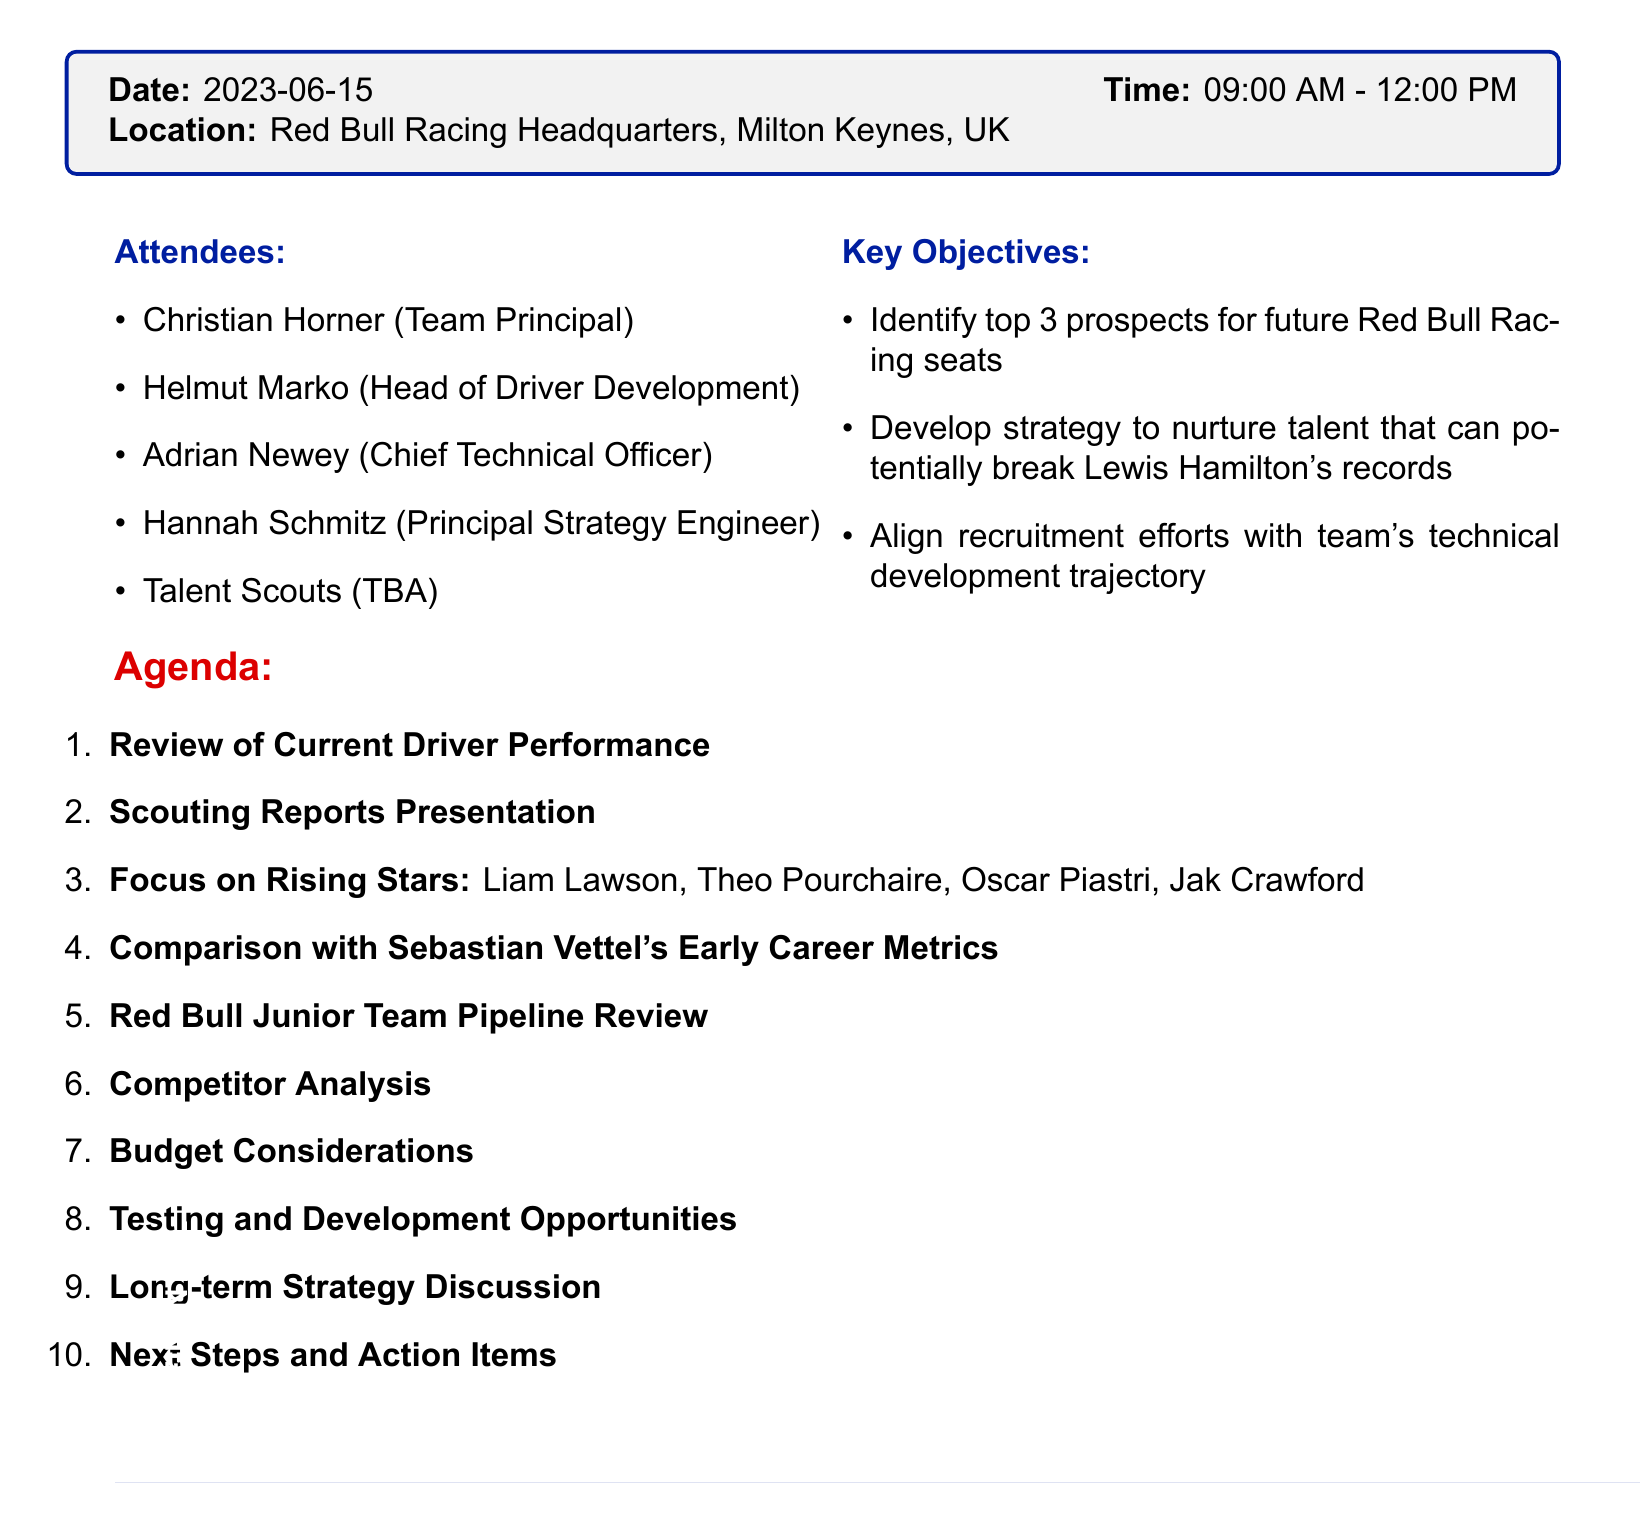What is the meeting title? The meeting title is the main heading of the document provided, summarizing the focus of the meeting.
Answer: Driver Recruitment and Scouting Report Review What is the date of the meeting? The date indicates when the meeting is scheduled to take place and is explicitly mentioned in the document.
Answer: 2023-06-15 Who are the attendees of the meeting? The attendees section lists the people who will participate in the meeting, relevant for understanding who will contribute.
Answer: Christian Horner, Helmut Marko, Adrian Newey, Hannah Schmitz, Talent Scouts (TBA) What is one of the key objectives of the meeting? The key objectives outline the goals of the meeting, emphasizing the focus on driver recruitment and future prospects.
Answer: Identify top 3 prospects for future Red Bull Racing seats What specific area does the "Focus on Rising Stars" agenda item address? This agenda item focuses on evaluating specific emerging drivers who are considered future talents, highlighting potential recruits.
Answer: Liam Lawson, Theo Pourchaire, Oscar Piastri, Jak Crawford How long is the meeting scheduled to last? The duration is inferred from the start and end times provided in the document, indicating how long participants should plan for.
Answer: 3 hours What is the purpose of the "Testing and Development Opportunities" agenda item? This item aims to plan for practical sessions, crucial for assessing the capabilities of prospective drivers through hands-on experience.
Answer: Plan for upcoming Young Driver Tests and Free Practice sessions Who do we compare the current prospects with in terms of performance metrics? The focus of this comparison is to contextualize the current potential drivers against a well-established benchmark from F1 history.
Answer: Sebastian Vettel's Early Career Metrics What will be discussed under the "Budget Considerations" agenda item? This item addresses the financial aspect of recruitment, crucial for strategically planning driver development and acquisitions.
Answer: Discuss financial implications of bringing in new talent vs. developing current drivers 